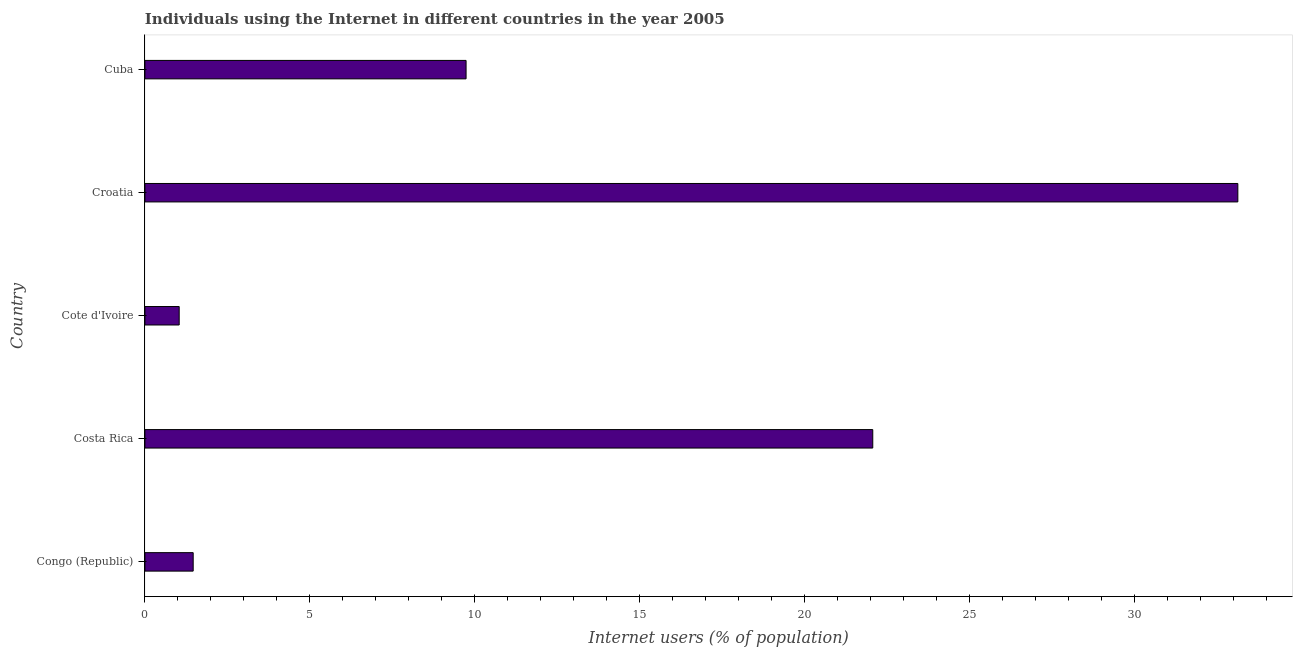Does the graph contain any zero values?
Your answer should be compact. No. Does the graph contain grids?
Offer a terse response. No. What is the title of the graph?
Offer a very short reply. Individuals using the Internet in different countries in the year 2005. What is the label or title of the X-axis?
Keep it short and to the point. Internet users (% of population). What is the number of internet users in Cuba?
Provide a short and direct response. 9.74. Across all countries, what is the maximum number of internet users?
Your answer should be compact. 33.14. Across all countries, what is the minimum number of internet users?
Offer a terse response. 1.04. In which country was the number of internet users maximum?
Provide a short and direct response. Croatia. In which country was the number of internet users minimum?
Provide a short and direct response. Cote d'Ivoire. What is the sum of the number of internet users?
Give a very brief answer. 67.45. What is the difference between the number of internet users in Costa Rica and Croatia?
Your response must be concise. -11.07. What is the average number of internet users per country?
Keep it short and to the point. 13.49. What is the median number of internet users?
Keep it short and to the point. 9.74. In how many countries, is the number of internet users greater than 1 %?
Provide a succinct answer. 5. What is the ratio of the number of internet users in Costa Rica to that in Cuba?
Provide a short and direct response. 2.27. Is the number of internet users in Congo (Republic) less than that in Costa Rica?
Your answer should be very brief. Yes. What is the difference between the highest and the second highest number of internet users?
Offer a very short reply. 11.07. Is the sum of the number of internet users in Congo (Republic) and Cuba greater than the maximum number of internet users across all countries?
Your answer should be very brief. No. What is the difference between the highest and the lowest number of internet users?
Give a very brief answer. 32.1. How many bars are there?
Provide a short and direct response. 5. Are all the bars in the graph horizontal?
Your answer should be compact. Yes. What is the difference between two consecutive major ticks on the X-axis?
Your answer should be very brief. 5. Are the values on the major ticks of X-axis written in scientific E-notation?
Provide a short and direct response. No. What is the Internet users (% of population) of Congo (Republic)?
Ensure brevity in your answer.  1.46. What is the Internet users (% of population) of Costa Rica?
Make the answer very short. 22.07. What is the Internet users (% of population) of Cote d'Ivoire?
Your response must be concise. 1.04. What is the Internet users (% of population) in Croatia?
Give a very brief answer. 33.14. What is the Internet users (% of population) in Cuba?
Offer a terse response. 9.74. What is the difference between the Internet users (% of population) in Congo (Republic) and Costa Rica?
Keep it short and to the point. -20.61. What is the difference between the Internet users (% of population) in Congo (Republic) and Cote d'Ivoire?
Your answer should be compact. 0.42. What is the difference between the Internet users (% of population) in Congo (Republic) and Croatia?
Ensure brevity in your answer.  -31.68. What is the difference between the Internet users (% of population) in Congo (Republic) and Cuba?
Offer a very short reply. -8.27. What is the difference between the Internet users (% of population) in Costa Rica and Cote d'Ivoire?
Your answer should be very brief. 21.03. What is the difference between the Internet users (% of population) in Costa Rica and Croatia?
Provide a succinct answer. -11.07. What is the difference between the Internet users (% of population) in Costa Rica and Cuba?
Your answer should be compact. 12.33. What is the difference between the Internet users (% of population) in Cote d'Ivoire and Croatia?
Provide a short and direct response. -32.1. What is the difference between the Internet users (% of population) in Cote d'Ivoire and Cuba?
Provide a succinct answer. -8.7. What is the difference between the Internet users (% of population) in Croatia and Cuba?
Ensure brevity in your answer.  23.4. What is the ratio of the Internet users (% of population) in Congo (Republic) to that in Costa Rica?
Offer a terse response. 0.07. What is the ratio of the Internet users (% of population) in Congo (Republic) to that in Cote d'Ivoire?
Offer a terse response. 1.41. What is the ratio of the Internet users (% of population) in Congo (Republic) to that in Croatia?
Offer a very short reply. 0.04. What is the ratio of the Internet users (% of population) in Costa Rica to that in Cote d'Ivoire?
Give a very brief answer. 21.24. What is the ratio of the Internet users (% of population) in Costa Rica to that in Croatia?
Keep it short and to the point. 0.67. What is the ratio of the Internet users (% of population) in Costa Rica to that in Cuba?
Provide a succinct answer. 2.27. What is the ratio of the Internet users (% of population) in Cote d'Ivoire to that in Croatia?
Keep it short and to the point. 0.03. What is the ratio of the Internet users (% of population) in Cote d'Ivoire to that in Cuba?
Your response must be concise. 0.11. What is the ratio of the Internet users (% of population) in Croatia to that in Cuba?
Ensure brevity in your answer.  3.4. 